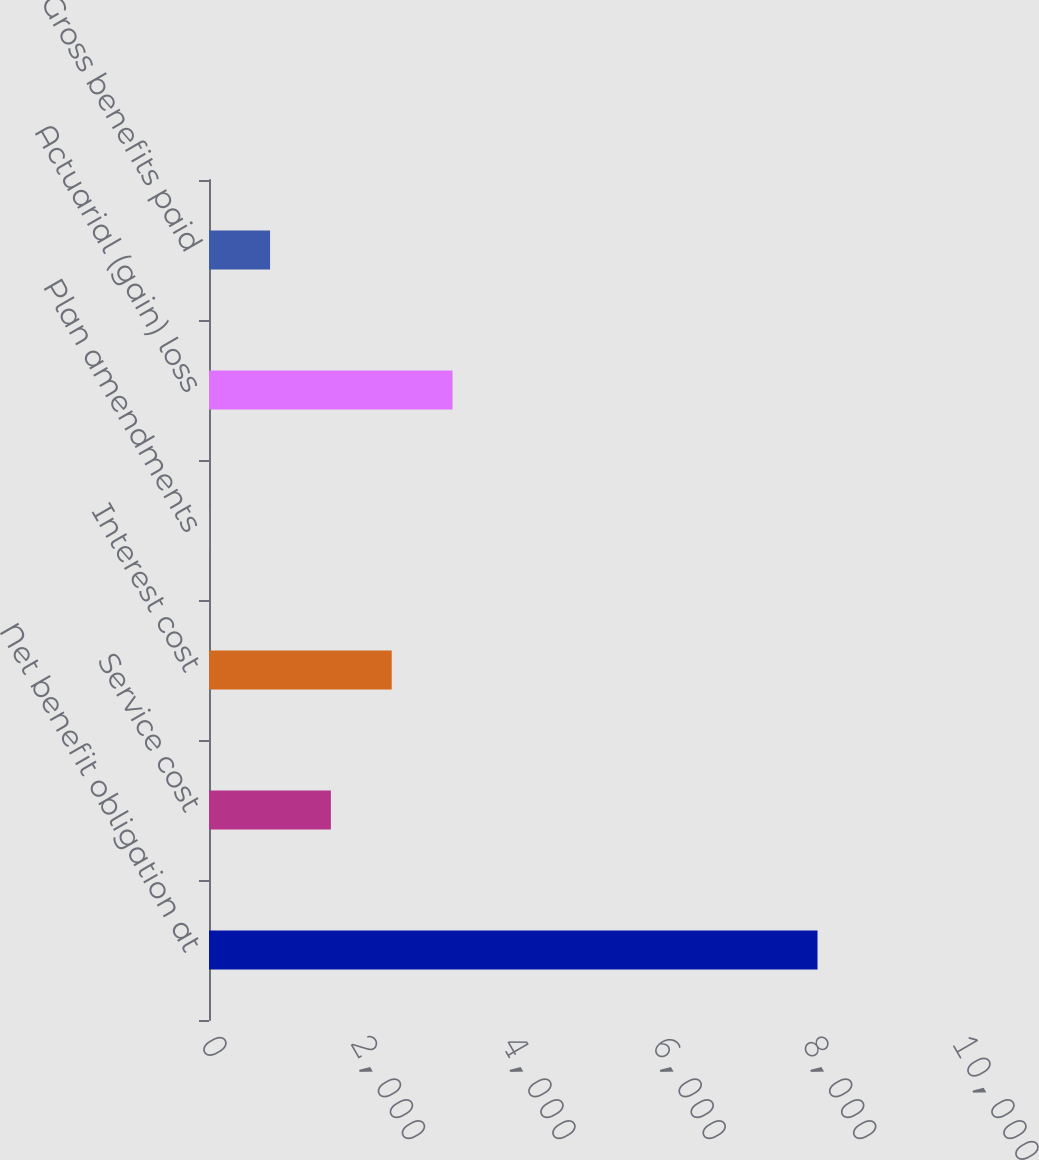Convert chart. <chart><loc_0><loc_0><loc_500><loc_500><bar_chart><fcel>Net benefit obligation at<fcel>Service cost<fcel>Interest cost<fcel>Plan amendments<fcel>Actuarial (gain) loss<fcel>Gross benefits paid<nl><fcel>8092<fcel>1620.8<fcel>2429.7<fcel>3<fcel>3238.6<fcel>811.9<nl></chart> 